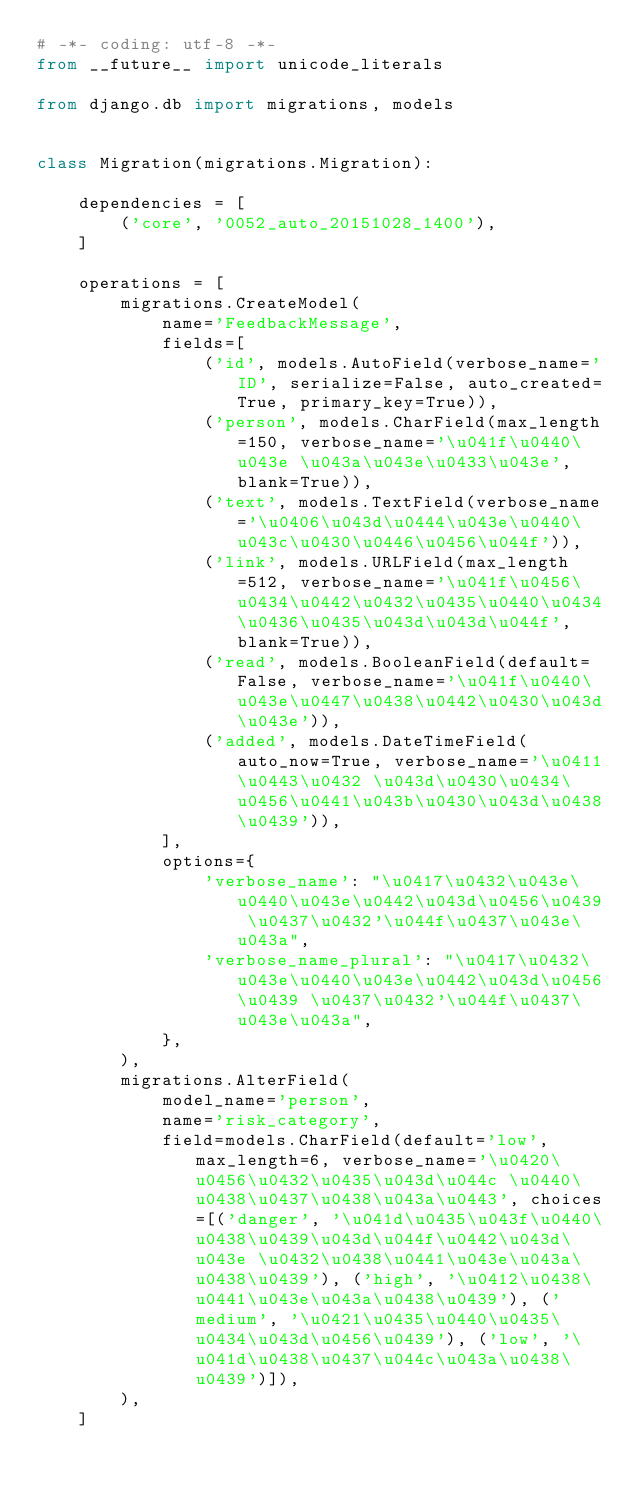<code> <loc_0><loc_0><loc_500><loc_500><_Python_># -*- coding: utf-8 -*-
from __future__ import unicode_literals

from django.db import migrations, models


class Migration(migrations.Migration):

    dependencies = [
        ('core', '0052_auto_20151028_1400'),
    ]

    operations = [
        migrations.CreateModel(
            name='FeedbackMessage',
            fields=[
                ('id', models.AutoField(verbose_name='ID', serialize=False, auto_created=True, primary_key=True)),
                ('person', models.CharField(max_length=150, verbose_name='\u041f\u0440\u043e \u043a\u043e\u0433\u043e', blank=True)),
                ('text', models.TextField(verbose_name='\u0406\u043d\u0444\u043e\u0440\u043c\u0430\u0446\u0456\u044f')),
                ('link', models.URLField(max_length=512, verbose_name='\u041f\u0456\u0434\u0442\u0432\u0435\u0440\u0434\u0436\u0435\u043d\u043d\u044f', blank=True)),
                ('read', models.BooleanField(default=False, verbose_name='\u041f\u0440\u043e\u0447\u0438\u0442\u0430\u043d\u043e')),
                ('added', models.DateTimeField(auto_now=True, verbose_name='\u0411\u0443\u0432 \u043d\u0430\u0434\u0456\u0441\u043b\u0430\u043d\u0438\u0439')),
            ],
            options={
                'verbose_name': "\u0417\u0432\u043e\u0440\u043e\u0442\u043d\u0456\u0439 \u0437\u0432'\u044f\u0437\u043e\u043a",
                'verbose_name_plural': "\u0417\u0432\u043e\u0440\u043e\u0442\u043d\u0456\u0439 \u0437\u0432'\u044f\u0437\u043e\u043a",
            },
        ),
        migrations.AlterField(
            model_name='person',
            name='risk_category',
            field=models.CharField(default='low', max_length=6, verbose_name='\u0420\u0456\u0432\u0435\u043d\u044c \u0440\u0438\u0437\u0438\u043a\u0443', choices=[('danger', '\u041d\u0435\u043f\u0440\u0438\u0439\u043d\u044f\u0442\u043d\u043e \u0432\u0438\u0441\u043e\u043a\u0438\u0439'), ('high', '\u0412\u0438\u0441\u043e\u043a\u0438\u0439'), ('medium', '\u0421\u0435\u0440\u0435\u0434\u043d\u0456\u0439'), ('low', '\u041d\u0438\u0437\u044c\u043a\u0438\u0439')]),
        ),
    ]
</code> 